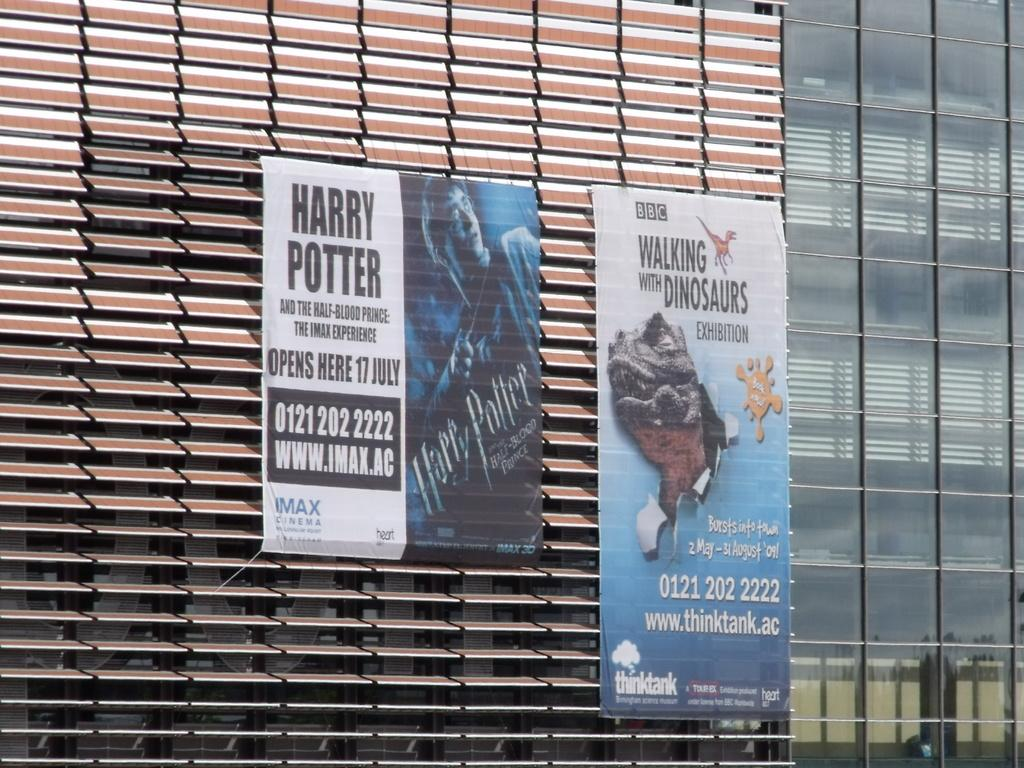<image>
Write a terse but informative summary of the picture. A poster displaying the release date for a Harry Potter movie along with an advert for a Walking with Dinosaurs exhibit. 